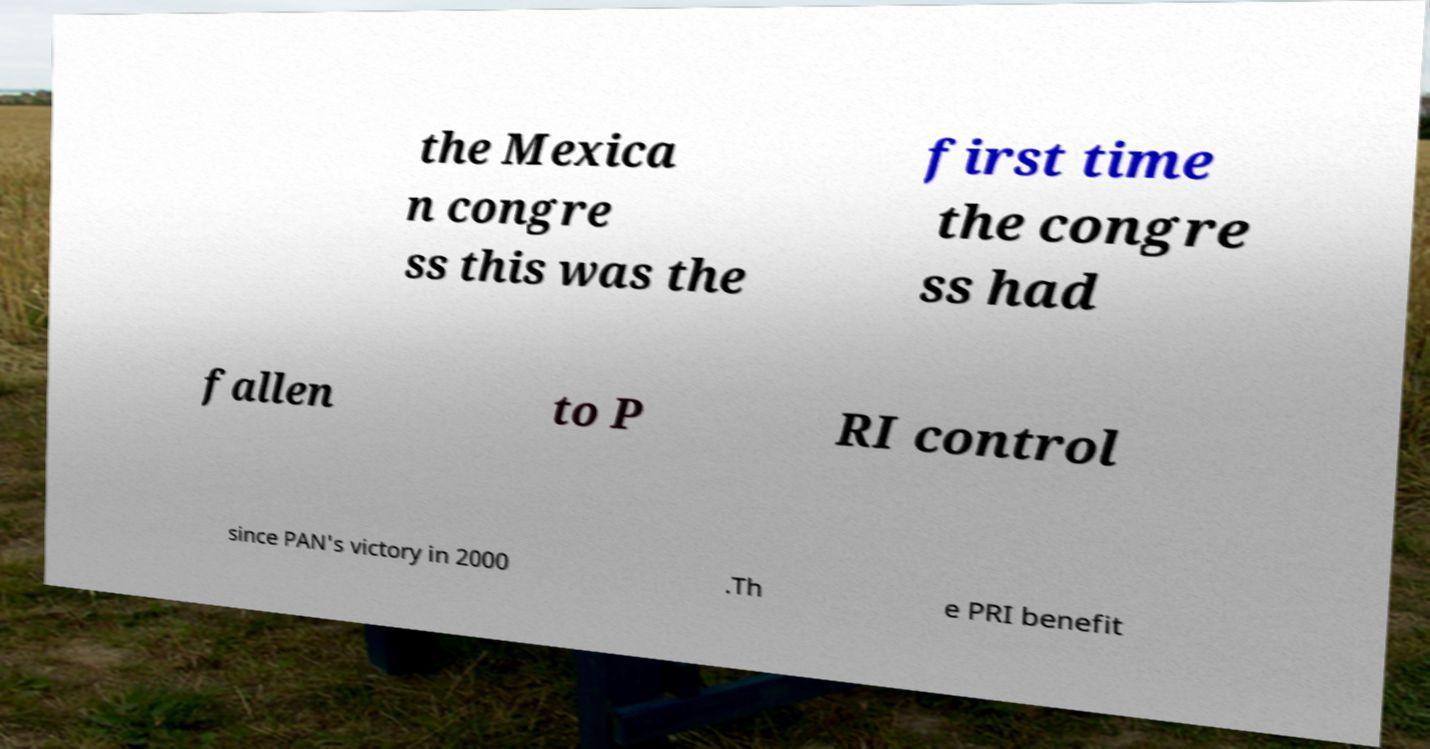Could you extract and type out the text from this image? the Mexica n congre ss this was the first time the congre ss had fallen to P RI control since PAN's victory in 2000 .Th e PRI benefit 